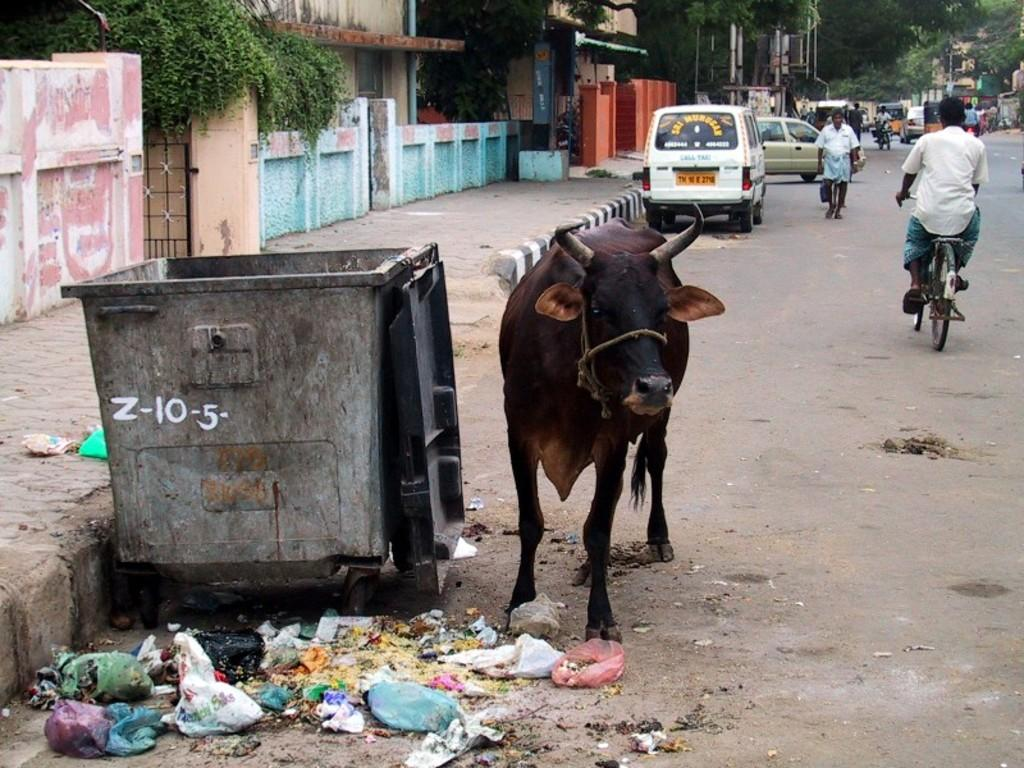What animal can be seen in the image? There is a cow in the image. Where is the cow located in relation to other objects in the image? The cow is near a dustbin. What type of vehicles are parked in the image? Cars are parked in the image. What is the man on the left side of the image doing? A man is riding a bicycle in the image. What is the man on the right side of the image doing? A man is walking on the road in the image. What type of building is visible in the image? There is a house in the image. What type of vegetation is present in the image? There are trees in the image. How many hands does the cow have in the image? Cows do not have hands; they have hooves. In the image, the cow has four hooves. 